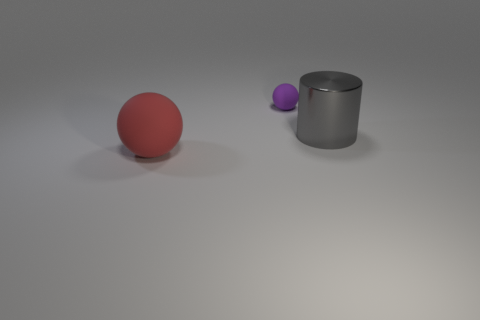Is the shape of the thing that is in front of the big metal cylinder the same as the large object that is to the right of the red rubber sphere? No, the shape of the small purple sphere in front of the big metal cylinder is not the same as the large red sphere to the right of the red rubber sphere. The smaller purple object is a sphere, just like the larger red one, but it is significantly smaller in size, and its color is purple, not red. 